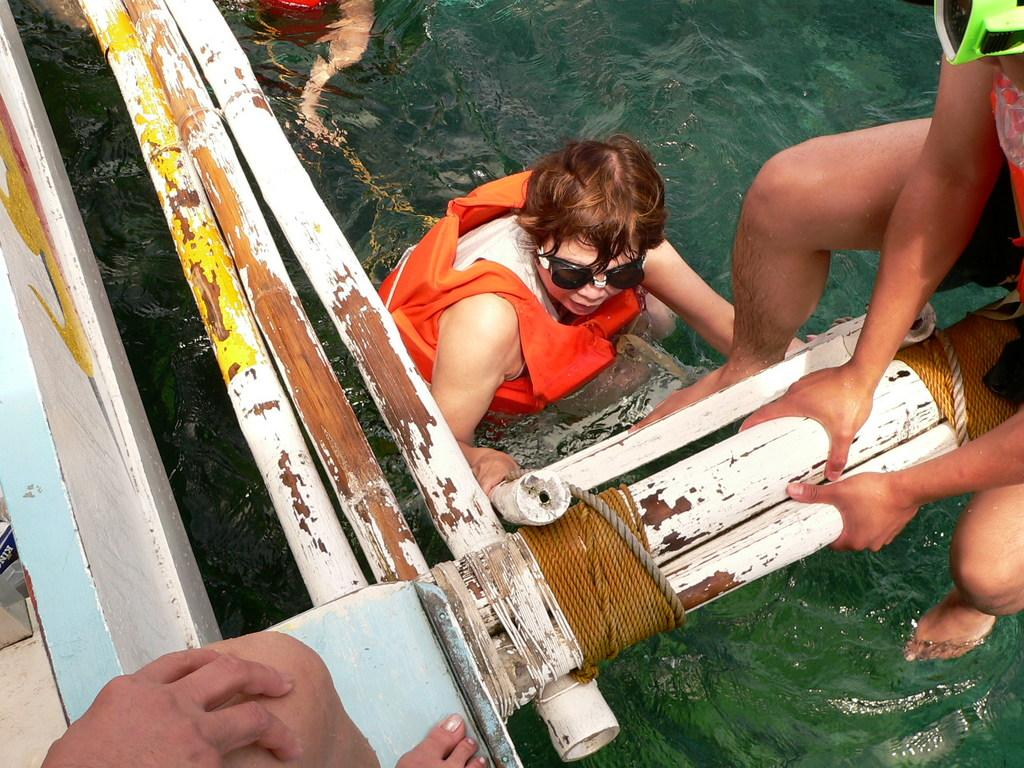How many people are in the image? There are few persons in the image. What can be seen at the bottom of the image? There is water visible at the bottom of the image. What is located on the left side of the image? There appears to be a boat on the left side of the image. What is the person in the water doing? The information provided does not specify what the person in the water is doing. What type of pear is being used as a cabbage substitute in the image? There is no pear or cabbage present in the image. 